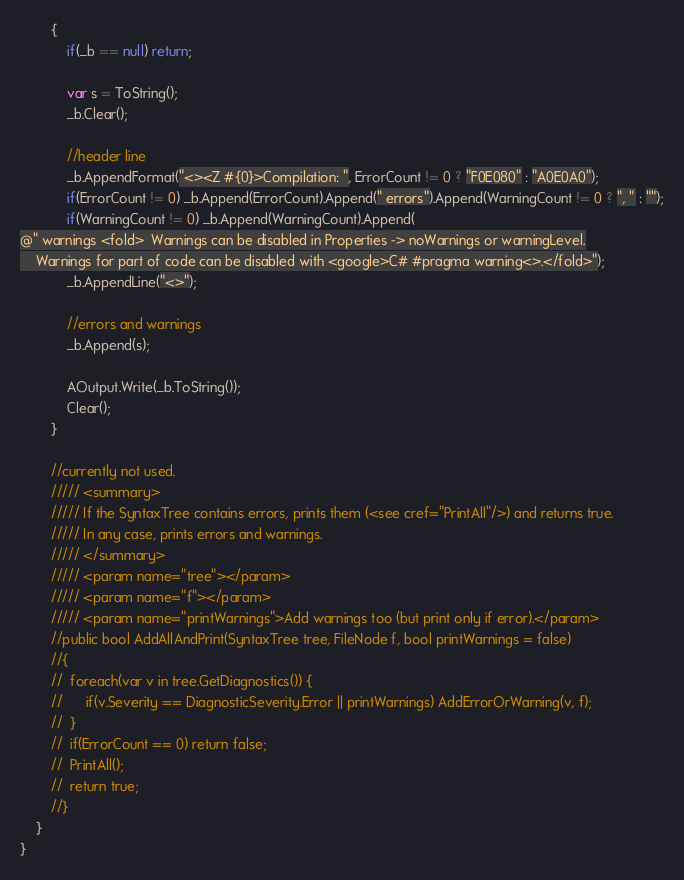<code> <loc_0><loc_0><loc_500><loc_500><_C#_>		{
			if(_b == null) return;

			var s = ToString();
			_b.Clear();

			//header line
			_b.AppendFormat("<><Z #{0}>Compilation: ", ErrorCount != 0 ? "F0E080" : "A0E0A0");
			if(ErrorCount != 0) _b.Append(ErrorCount).Append(" errors").Append(WarningCount != 0 ? ", " : "");
			if(WarningCount != 0) _b.Append(WarningCount).Append(
@" warnings <fold>	Warnings can be disabled in Properties -> noWarnings or warningLevel.
	Warnings for part of code can be disabled with <google>C# #pragma warning<>.</fold>");
			_b.AppendLine("<>");

			//errors and warnings
			_b.Append(s);

			AOutput.Write(_b.ToString());
			Clear();
		}

		//currently not used.
		///// <summary>
		///// If the SyntaxTree contains errors, prints them (<see cref="PrintAll"/>) and returns true.
		///// In any case, prints errors and warnings.
		///// </summary>
		///// <param name="tree"></param>
		///// <param name="f"></param>
		///// <param name="printWarnings">Add warnings too (but print only if error).</param>
		//public bool AddAllAndPrint(SyntaxTree tree, FileNode f, bool printWarnings = false)
		//{
		//	foreach(var v in tree.GetDiagnostics()) {
		//		if(v.Severity == DiagnosticSeverity.Error || printWarnings) AddErrorOrWarning(v, f);
		//	}
		//	if(ErrorCount == 0) return false;
		//	PrintAll();
		//	return true;
		//}
	}
}
</code> 